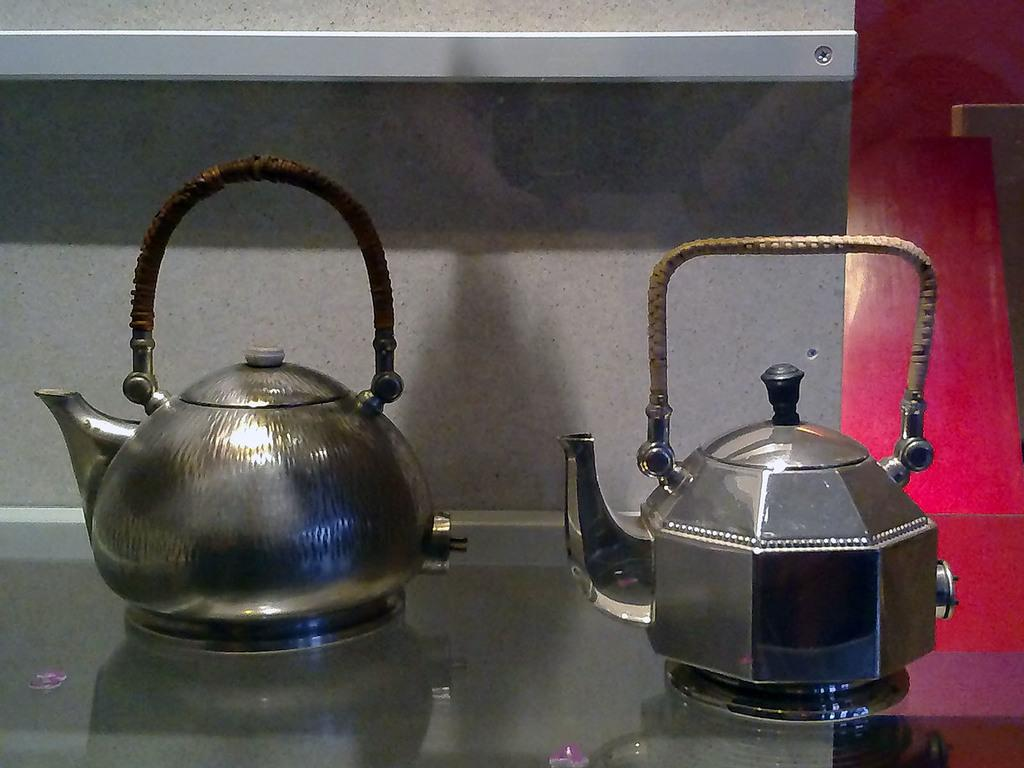What objects are present on the surface in the image? There are teapots on a surface in the image. What can be seen in the background of the image? There is a wall in the background of the image. What type of creature is sitting on the teapots in the image? There is no creature present on the teapots in the image. How many chairs are visible in the image? There are no chairs visible in the image. 